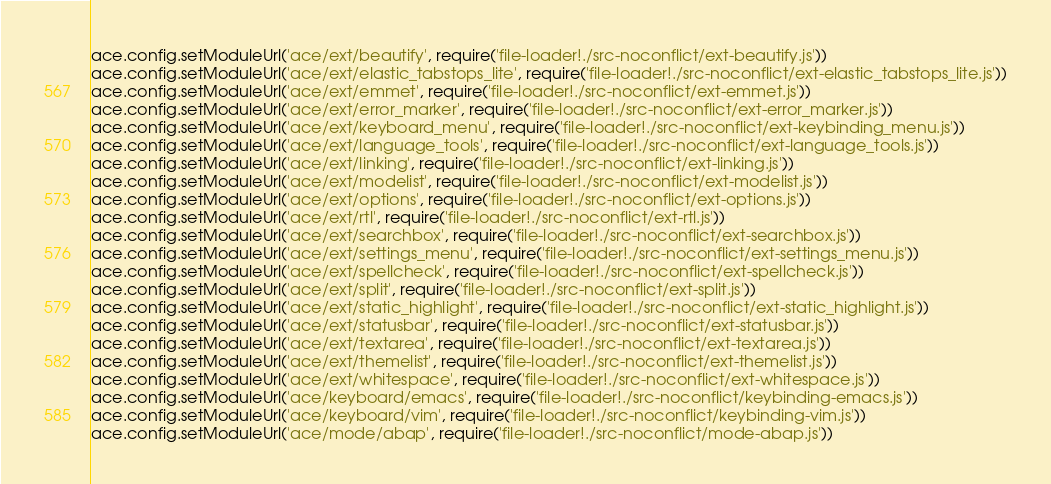Convert code to text. <code><loc_0><loc_0><loc_500><loc_500><_JavaScript_>
ace.config.setModuleUrl('ace/ext/beautify', require('file-loader!./src-noconflict/ext-beautify.js'))
ace.config.setModuleUrl('ace/ext/elastic_tabstops_lite', require('file-loader!./src-noconflict/ext-elastic_tabstops_lite.js'))
ace.config.setModuleUrl('ace/ext/emmet', require('file-loader!./src-noconflict/ext-emmet.js'))
ace.config.setModuleUrl('ace/ext/error_marker', require('file-loader!./src-noconflict/ext-error_marker.js'))
ace.config.setModuleUrl('ace/ext/keyboard_menu', require('file-loader!./src-noconflict/ext-keybinding_menu.js'))
ace.config.setModuleUrl('ace/ext/language_tools', require('file-loader!./src-noconflict/ext-language_tools.js'))
ace.config.setModuleUrl('ace/ext/linking', require('file-loader!./src-noconflict/ext-linking.js'))
ace.config.setModuleUrl('ace/ext/modelist', require('file-loader!./src-noconflict/ext-modelist.js'))
ace.config.setModuleUrl('ace/ext/options', require('file-loader!./src-noconflict/ext-options.js'))
ace.config.setModuleUrl('ace/ext/rtl', require('file-loader!./src-noconflict/ext-rtl.js'))
ace.config.setModuleUrl('ace/ext/searchbox', require('file-loader!./src-noconflict/ext-searchbox.js'))
ace.config.setModuleUrl('ace/ext/settings_menu', require('file-loader!./src-noconflict/ext-settings_menu.js'))
ace.config.setModuleUrl('ace/ext/spellcheck', require('file-loader!./src-noconflict/ext-spellcheck.js'))
ace.config.setModuleUrl('ace/ext/split', require('file-loader!./src-noconflict/ext-split.js'))
ace.config.setModuleUrl('ace/ext/static_highlight', require('file-loader!./src-noconflict/ext-static_highlight.js'))
ace.config.setModuleUrl('ace/ext/statusbar', require('file-loader!./src-noconflict/ext-statusbar.js'))
ace.config.setModuleUrl('ace/ext/textarea', require('file-loader!./src-noconflict/ext-textarea.js'))
ace.config.setModuleUrl('ace/ext/themelist', require('file-loader!./src-noconflict/ext-themelist.js'))
ace.config.setModuleUrl('ace/ext/whitespace', require('file-loader!./src-noconflict/ext-whitespace.js'))
ace.config.setModuleUrl('ace/keyboard/emacs', require('file-loader!./src-noconflict/keybinding-emacs.js'))
ace.config.setModuleUrl('ace/keyboard/vim', require('file-loader!./src-noconflict/keybinding-vim.js'))
ace.config.setModuleUrl('ace/mode/abap', require('file-loader!./src-noconflict/mode-abap.js'))</code> 